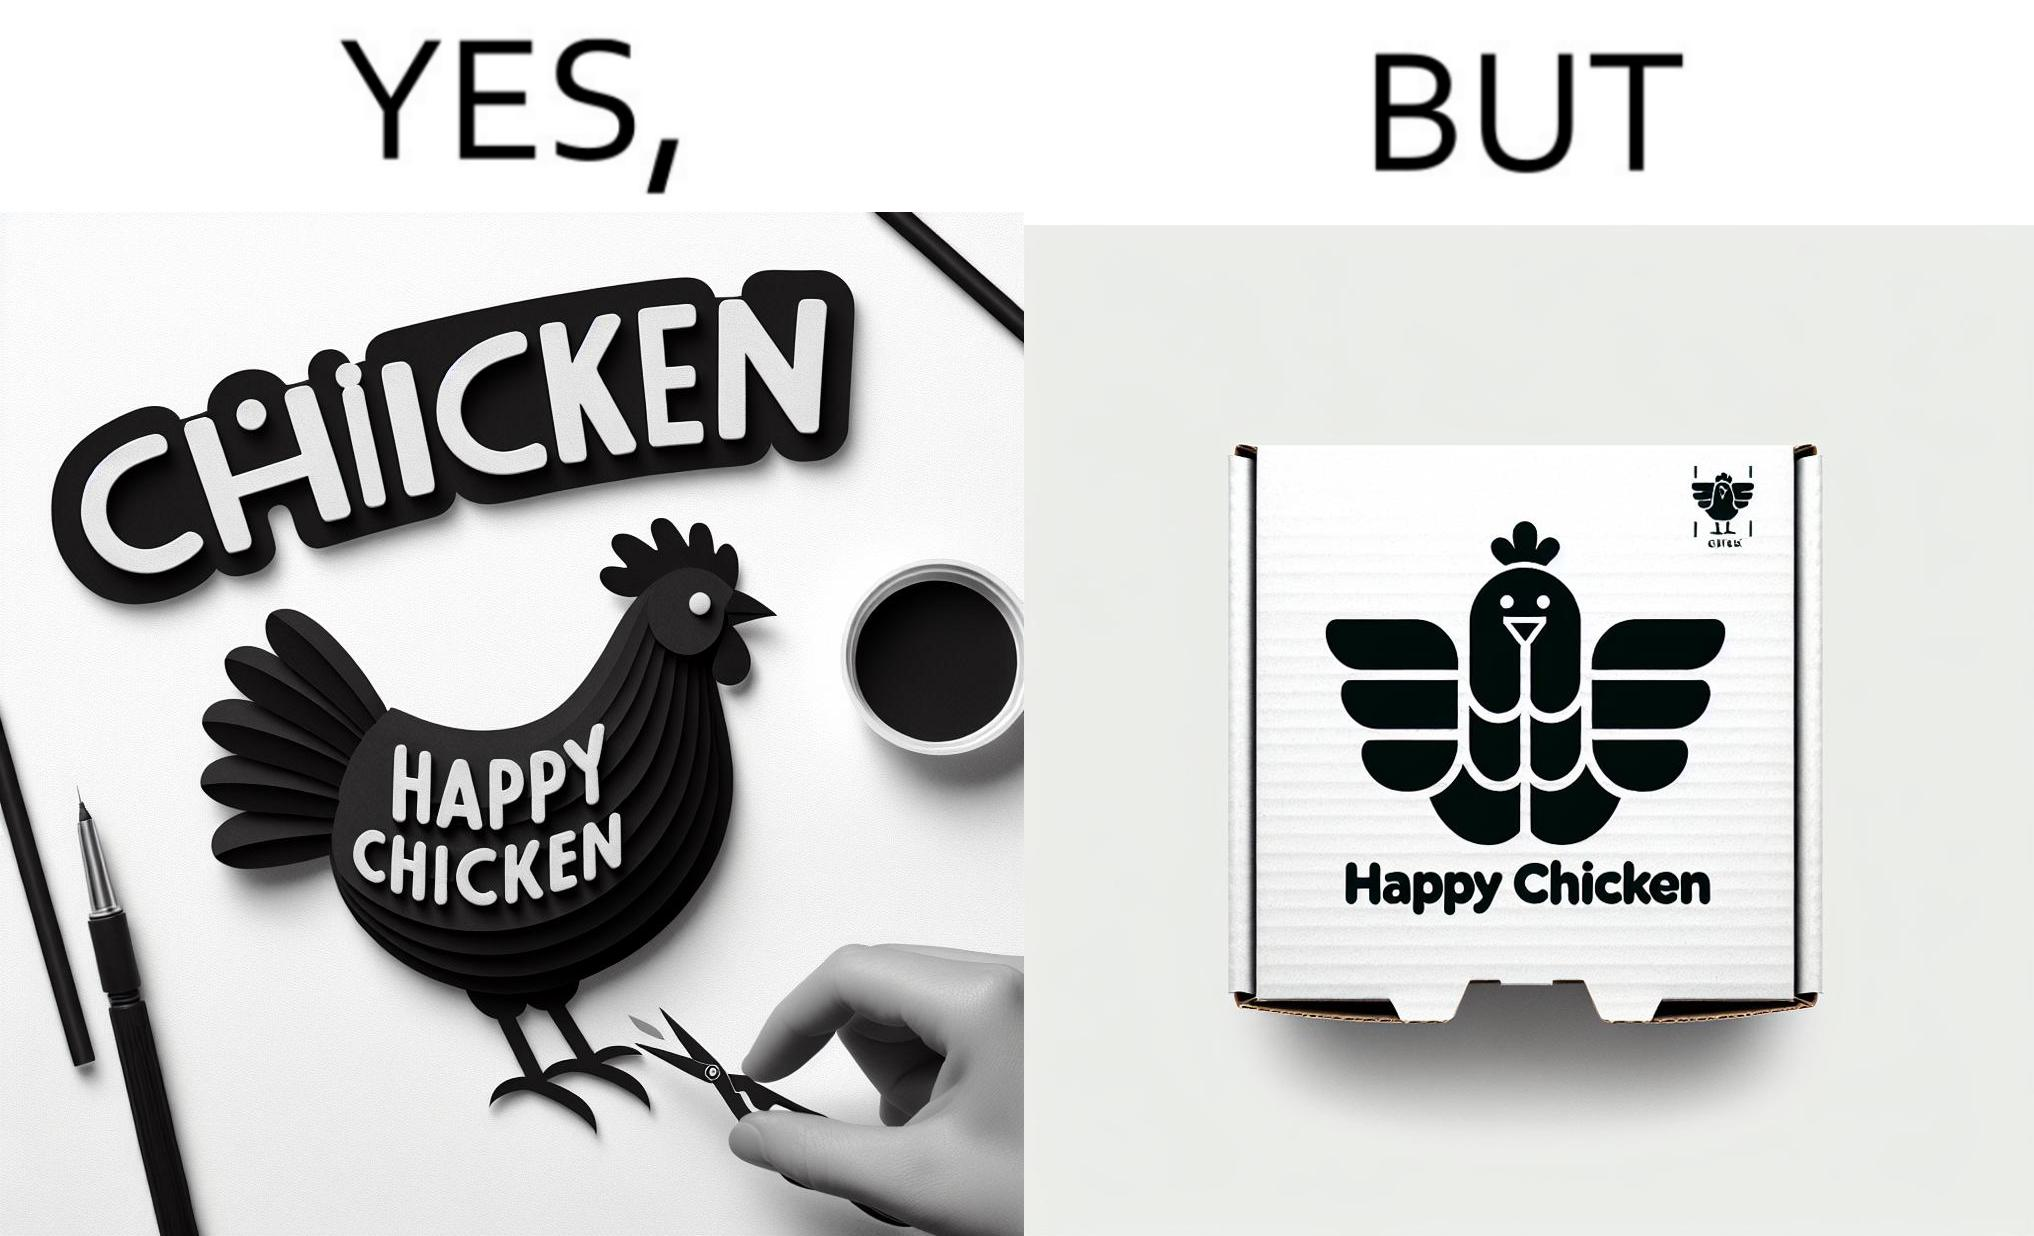Explain why this image is satirical. The image is ironic, because in the left image as in the logo it shows happy chicken but in the right image the chicken pieces are shown packed in boxes 